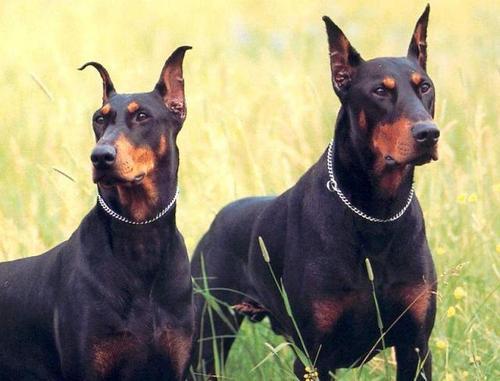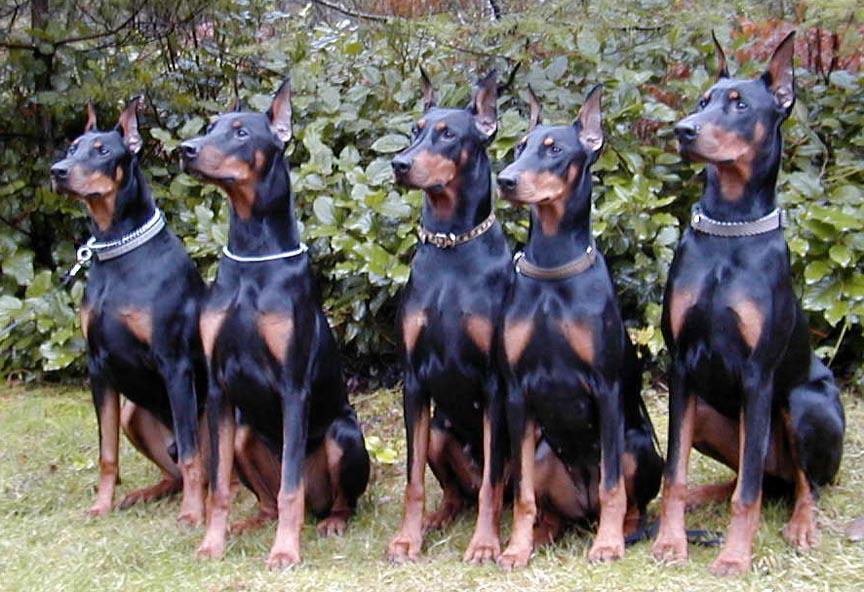The first image is the image on the left, the second image is the image on the right. Considering the images on both sides, is "The right image contains exactly five dogs." valid? Answer yes or no. Yes. The first image is the image on the left, the second image is the image on the right. Given the left and right images, does the statement "All dogs are pointy-eared adult dobermans, and at least seven dogs in total are shown." hold true? Answer yes or no. Yes. 